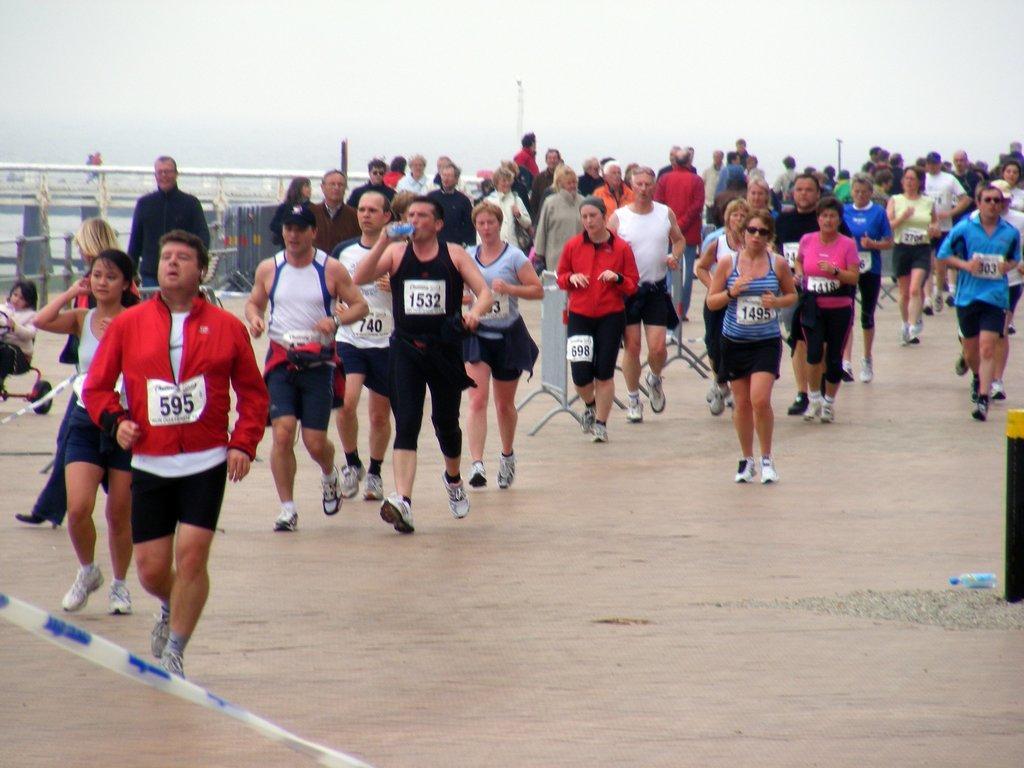In one or two sentences, can you explain what this image depicts? In this image there are so many people who are jogging on the floor by wearing the shoes. In the background it seems like a bridge. 